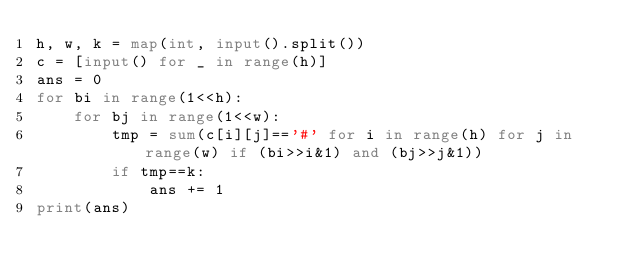<code> <loc_0><loc_0><loc_500><loc_500><_Python_>h, w, k = map(int, input().split())
c = [input() for _ in range(h)]
ans = 0
for bi in range(1<<h):
    for bj in range(1<<w):
        tmp = sum(c[i][j]=='#' for i in range(h) for j in range(w) if (bi>>i&1) and (bj>>j&1))
        if tmp==k:
            ans += 1
print(ans)</code> 